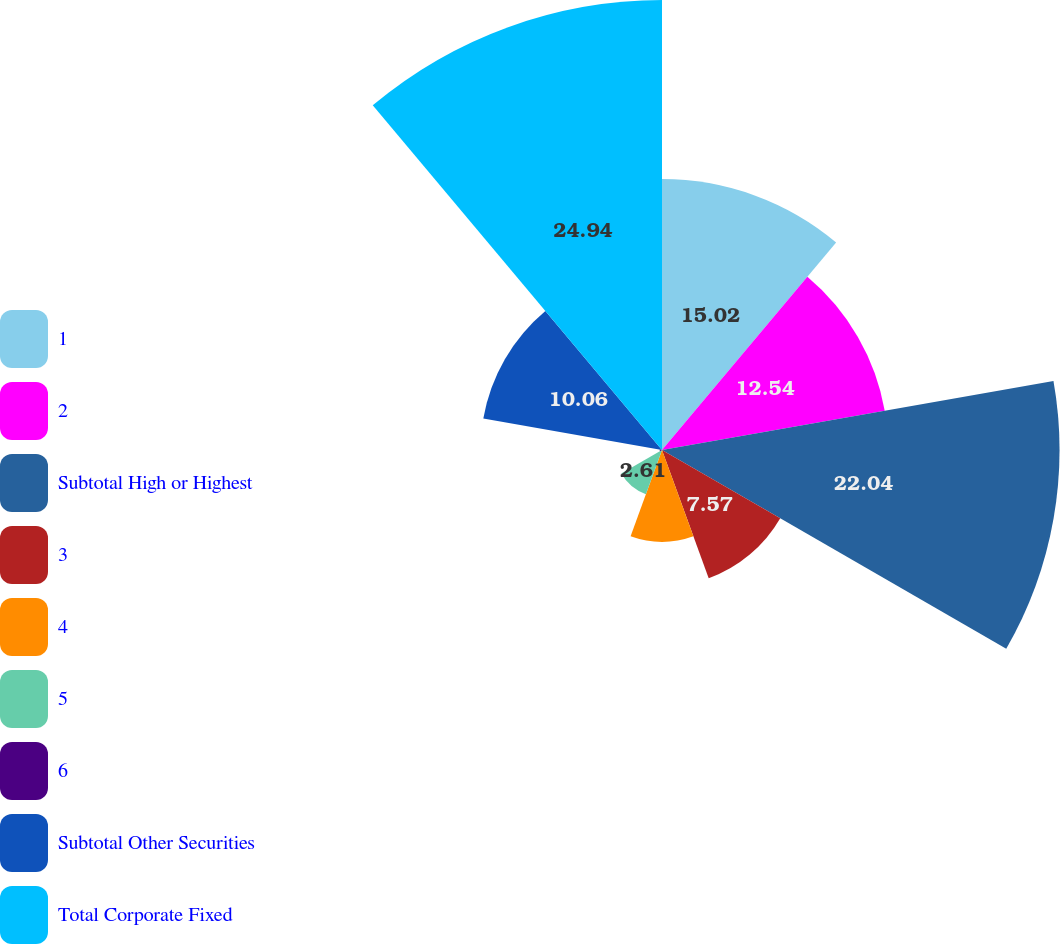Convert chart to OTSL. <chart><loc_0><loc_0><loc_500><loc_500><pie_chart><fcel>1<fcel>2<fcel>Subtotal High or Highest<fcel>3<fcel>4<fcel>5<fcel>6<fcel>Subtotal Other Securities<fcel>Total Corporate Fixed<nl><fcel>15.02%<fcel>12.54%<fcel>22.04%<fcel>7.57%<fcel>5.09%<fcel>2.61%<fcel>0.13%<fcel>10.06%<fcel>24.95%<nl></chart> 